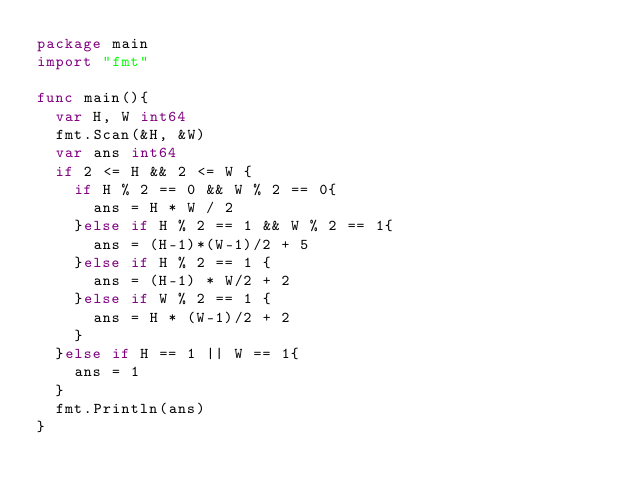Convert code to text. <code><loc_0><loc_0><loc_500><loc_500><_Go_>package main
import "fmt"

func main(){
	var H, W int64
	fmt.Scan(&H, &W)
	var ans int64
	if 2 <= H && 2 <= W {
		if H % 2 == 0 && W % 2 == 0{
			ans = H * W / 2
		}else if H % 2 == 1 && W % 2 == 1{
			ans = (H-1)*(W-1)/2 + 5
		}else if H % 2 == 1 {
			ans = (H-1) * W/2 + 2
		}else if W % 2 == 1 {
			ans = H * (W-1)/2 + 2
		}
	}else if H == 1 || W == 1{
		ans = 1
	}
	fmt.Println(ans)
}</code> 